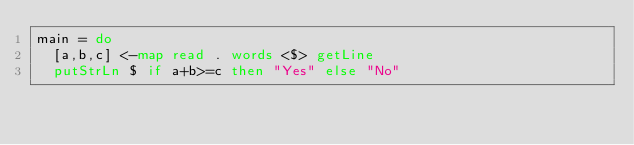Convert code to text. <code><loc_0><loc_0><loc_500><loc_500><_Haskell_>main = do
  [a,b,c] <-map read . words <$> getLine
  putStrLn $ if a+b>=c then "Yes" else "No"</code> 